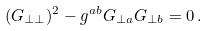<formula> <loc_0><loc_0><loc_500><loc_500>( G _ { \perp \perp } ) ^ { 2 } - g ^ { a b } G _ { \perp a } G _ { \perp b } = 0 \, .</formula> 